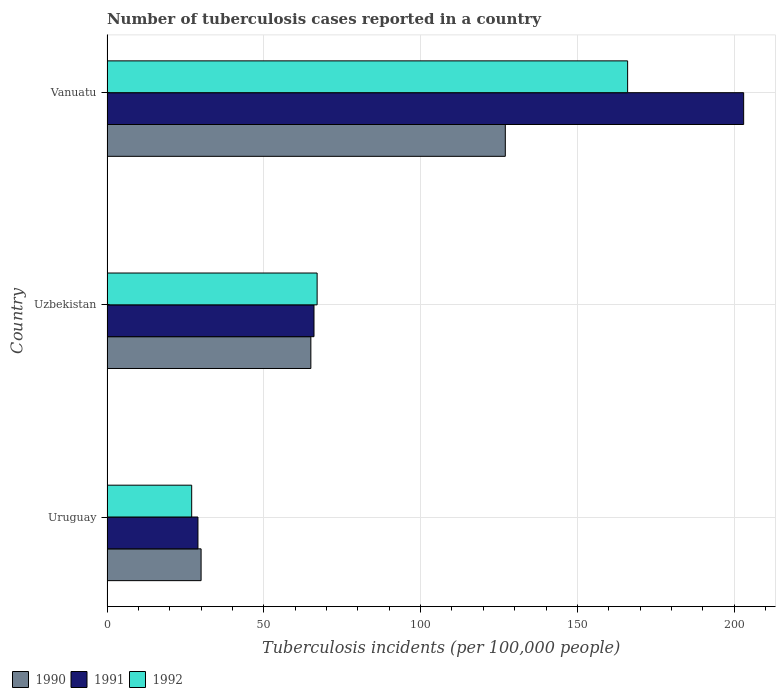What is the label of the 1st group of bars from the top?
Offer a very short reply. Vanuatu. In how many cases, is the number of bars for a given country not equal to the number of legend labels?
Offer a very short reply. 0. What is the number of tuberculosis cases reported in in 1991 in Uzbekistan?
Keep it short and to the point. 66. Across all countries, what is the maximum number of tuberculosis cases reported in in 1992?
Ensure brevity in your answer.  166. Across all countries, what is the minimum number of tuberculosis cases reported in in 1990?
Provide a succinct answer. 30. In which country was the number of tuberculosis cases reported in in 1990 maximum?
Your answer should be very brief. Vanuatu. In which country was the number of tuberculosis cases reported in in 1992 minimum?
Offer a terse response. Uruguay. What is the total number of tuberculosis cases reported in in 1991 in the graph?
Offer a very short reply. 298. What is the difference between the number of tuberculosis cases reported in in 1992 in Uzbekistan and that in Vanuatu?
Your response must be concise. -99. What is the difference between the number of tuberculosis cases reported in in 1992 in Uzbekistan and the number of tuberculosis cases reported in in 1991 in Uruguay?
Offer a terse response. 38. What is the average number of tuberculosis cases reported in in 1991 per country?
Your answer should be very brief. 99.33. What is the difference between the number of tuberculosis cases reported in in 1991 and number of tuberculosis cases reported in in 1992 in Vanuatu?
Offer a terse response. 37. What is the ratio of the number of tuberculosis cases reported in in 1992 in Uzbekistan to that in Vanuatu?
Your response must be concise. 0.4. Is the number of tuberculosis cases reported in in 1992 in Uruguay less than that in Vanuatu?
Ensure brevity in your answer.  Yes. What is the difference between the highest and the second highest number of tuberculosis cases reported in in 1991?
Provide a succinct answer. 137. What is the difference between the highest and the lowest number of tuberculosis cases reported in in 1991?
Offer a very short reply. 174. In how many countries, is the number of tuberculosis cases reported in in 1990 greater than the average number of tuberculosis cases reported in in 1990 taken over all countries?
Your response must be concise. 1. Is the sum of the number of tuberculosis cases reported in in 1991 in Uzbekistan and Vanuatu greater than the maximum number of tuberculosis cases reported in in 1992 across all countries?
Provide a short and direct response. Yes. Is it the case that in every country, the sum of the number of tuberculosis cases reported in in 1992 and number of tuberculosis cases reported in in 1991 is greater than the number of tuberculosis cases reported in in 1990?
Your response must be concise. Yes. Are all the bars in the graph horizontal?
Your answer should be compact. Yes. How many countries are there in the graph?
Ensure brevity in your answer.  3. What is the difference between two consecutive major ticks on the X-axis?
Make the answer very short. 50. Does the graph contain grids?
Provide a short and direct response. Yes. How are the legend labels stacked?
Your response must be concise. Horizontal. What is the title of the graph?
Provide a succinct answer. Number of tuberculosis cases reported in a country. What is the label or title of the X-axis?
Your answer should be compact. Tuberculosis incidents (per 100,0 people). What is the Tuberculosis incidents (per 100,000 people) in 1990 in Uruguay?
Provide a short and direct response. 30. What is the Tuberculosis incidents (per 100,000 people) in 1991 in Uruguay?
Provide a succinct answer. 29. What is the Tuberculosis incidents (per 100,000 people) of 1992 in Uruguay?
Your answer should be compact. 27. What is the Tuberculosis incidents (per 100,000 people) in 1990 in Uzbekistan?
Make the answer very short. 65. What is the Tuberculosis incidents (per 100,000 people) in 1991 in Uzbekistan?
Your answer should be very brief. 66. What is the Tuberculosis incidents (per 100,000 people) of 1992 in Uzbekistan?
Your answer should be very brief. 67. What is the Tuberculosis incidents (per 100,000 people) in 1990 in Vanuatu?
Make the answer very short. 127. What is the Tuberculosis incidents (per 100,000 people) in 1991 in Vanuatu?
Provide a succinct answer. 203. What is the Tuberculosis incidents (per 100,000 people) in 1992 in Vanuatu?
Give a very brief answer. 166. Across all countries, what is the maximum Tuberculosis incidents (per 100,000 people) in 1990?
Your answer should be very brief. 127. Across all countries, what is the maximum Tuberculosis incidents (per 100,000 people) in 1991?
Your answer should be compact. 203. Across all countries, what is the maximum Tuberculosis incidents (per 100,000 people) of 1992?
Your response must be concise. 166. What is the total Tuberculosis incidents (per 100,000 people) of 1990 in the graph?
Ensure brevity in your answer.  222. What is the total Tuberculosis incidents (per 100,000 people) of 1991 in the graph?
Ensure brevity in your answer.  298. What is the total Tuberculosis incidents (per 100,000 people) in 1992 in the graph?
Your response must be concise. 260. What is the difference between the Tuberculosis incidents (per 100,000 people) of 1990 in Uruguay and that in Uzbekistan?
Give a very brief answer. -35. What is the difference between the Tuberculosis incidents (per 100,000 people) in 1991 in Uruguay and that in Uzbekistan?
Make the answer very short. -37. What is the difference between the Tuberculosis incidents (per 100,000 people) in 1990 in Uruguay and that in Vanuatu?
Provide a short and direct response. -97. What is the difference between the Tuberculosis incidents (per 100,000 people) of 1991 in Uruguay and that in Vanuatu?
Your answer should be very brief. -174. What is the difference between the Tuberculosis incidents (per 100,000 people) of 1992 in Uruguay and that in Vanuatu?
Ensure brevity in your answer.  -139. What is the difference between the Tuberculosis incidents (per 100,000 people) in 1990 in Uzbekistan and that in Vanuatu?
Make the answer very short. -62. What is the difference between the Tuberculosis incidents (per 100,000 people) in 1991 in Uzbekistan and that in Vanuatu?
Make the answer very short. -137. What is the difference between the Tuberculosis incidents (per 100,000 people) of 1992 in Uzbekistan and that in Vanuatu?
Provide a succinct answer. -99. What is the difference between the Tuberculosis incidents (per 100,000 people) in 1990 in Uruguay and the Tuberculosis incidents (per 100,000 people) in 1991 in Uzbekistan?
Ensure brevity in your answer.  -36. What is the difference between the Tuberculosis incidents (per 100,000 people) in 1990 in Uruguay and the Tuberculosis incidents (per 100,000 people) in 1992 in Uzbekistan?
Offer a very short reply. -37. What is the difference between the Tuberculosis incidents (per 100,000 people) in 1991 in Uruguay and the Tuberculosis incidents (per 100,000 people) in 1992 in Uzbekistan?
Make the answer very short. -38. What is the difference between the Tuberculosis incidents (per 100,000 people) in 1990 in Uruguay and the Tuberculosis incidents (per 100,000 people) in 1991 in Vanuatu?
Provide a short and direct response. -173. What is the difference between the Tuberculosis incidents (per 100,000 people) in 1990 in Uruguay and the Tuberculosis incidents (per 100,000 people) in 1992 in Vanuatu?
Provide a succinct answer. -136. What is the difference between the Tuberculosis incidents (per 100,000 people) of 1991 in Uruguay and the Tuberculosis incidents (per 100,000 people) of 1992 in Vanuatu?
Make the answer very short. -137. What is the difference between the Tuberculosis incidents (per 100,000 people) of 1990 in Uzbekistan and the Tuberculosis incidents (per 100,000 people) of 1991 in Vanuatu?
Your answer should be very brief. -138. What is the difference between the Tuberculosis incidents (per 100,000 people) of 1990 in Uzbekistan and the Tuberculosis incidents (per 100,000 people) of 1992 in Vanuatu?
Provide a short and direct response. -101. What is the difference between the Tuberculosis incidents (per 100,000 people) in 1991 in Uzbekistan and the Tuberculosis incidents (per 100,000 people) in 1992 in Vanuatu?
Your answer should be very brief. -100. What is the average Tuberculosis incidents (per 100,000 people) of 1990 per country?
Provide a succinct answer. 74. What is the average Tuberculosis incidents (per 100,000 people) in 1991 per country?
Your answer should be compact. 99.33. What is the average Tuberculosis incidents (per 100,000 people) in 1992 per country?
Offer a very short reply. 86.67. What is the difference between the Tuberculosis incidents (per 100,000 people) of 1990 and Tuberculosis incidents (per 100,000 people) of 1991 in Uruguay?
Your response must be concise. 1. What is the difference between the Tuberculosis incidents (per 100,000 people) in 1991 and Tuberculosis incidents (per 100,000 people) in 1992 in Uruguay?
Offer a very short reply. 2. What is the difference between the Tuberculosis incidents (per 100,000 people) of 1990 and Tuberculosis incidents (per 100,000 people) of 1991 in Uzbekistan?
Your response must be concise. -1. What is the difference between the Tuberculosis incidents (per 100,000 people) in 1990 and Tuberculosis incidents (per 100,000 people) in 1991 in Vanuatu?
Keep it short and to the point. -76. What is the difference between the Tuberculosis incidents (per 100,000 people) in 1990 and Tuberculosis incidents (per 100,000 people) in 1992 in Vanuatu?
Offer a terse response. -39. What is the ratio of the Tuberculosis incidents (per 100,000 people) of 1990 in Uruguay to that in Uzbekistan?
Provide a succinct answer. 0.46. What is the ratio of the Tuberculosis incidents (per 100,000 people) of 1991 in Uruguay to that in Uzbekistan?
Make the answer very short. 0.44. What is the ratio of the Tuberculosis incidents (per 100,000 people) of 1992 in Uruguay to that in Uzbekistan?
Offer a very short reply. 0.4. What is the ratio of the Tuberculosis incidents (per 100,000 people) of 1990 in Uruguay to that in Vanuatu?
Your answer should be compact. 0.24. What is the ratio of the Tuberculosis incidents (per 100,000 people) in 1991 in Uruguay to that in Vanuatu?
Your answer should be very brief. 0.14. What is the ratio of the Tuberculosis incidents (per 100,000 people) in 1992 in Uruguay to that in Vanuatu?
Offer a terse response. 0.16. What is the ratio of the Tuberculosis incidents (per 100,000 people) in 1990 in Uzbekistan to that in Vanuatu?
Keep it short and to the point. 0.51. What is the ratio of the Tuberculosis incidents (per 100,000 people) of 1991 in Uzbekistan to that in Vanuatu?
Offer a terse response. 0.33. What is the ratio of the Tuberculosis incidents (per 100,000 people) in 1992 in Uzbekistan to that in Vanuatu?
Give a very brief answer. 0.4. What is the difference between the highest and the second highest Tuberculosis incidents (per 100,000 people) in 1990?
Give a very brief answer. 62. What is the difference between the highest and the second highest Tuberculosis incidents (per 100,000 people) in 1991?
Make the answer very short. 137. What is the difference between the highest and the lowest Tuberculosis incidents (per 100,000 people) of 1990?
Provide a succinct answer. 97. What is the difference between the highest and the lowest Tuberculosis incidents (per 100,000 people) in 1991?
Your answer should be very brief. 174. What is the difference between the highest and the lowest Tuberculosis incidents (per 100,000 people) of 1992?
Provide a short and direct response. 139. 